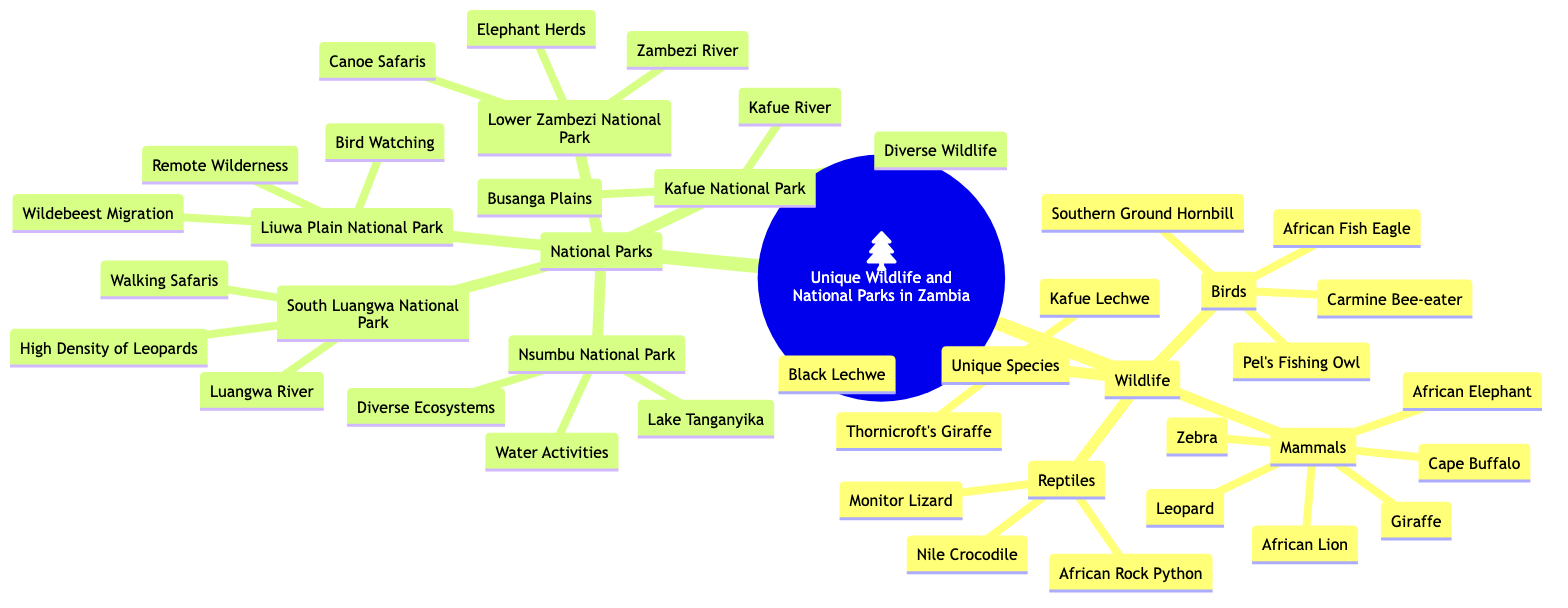What unique species are found in Zambia? The diagram lists "Kafue Lechwe," "Black Lechwe," and "Thornicroft's Giraffe" under the Unique Species branch of Wildlife. These are identified as unique to the region.
Answer: Kafue Lechwe, Black Lechwe, Thornicroft's Giraffe How many mammals are listed in the wildlife section? In the Wildlife section, there are six mammals mentioned: African Elephant, African Lion, Leopard, Cape Buffalo, Zebra, and Giraffe. By counting these, we arrive at the total.
Answer: 6 What national park is highlighted for walking safaris? The South Luangwa National Park branch directly states "Walking Safaris" as one of its highlights. This indicates its significance for such activities.
Answer: South Luangwa National Park Which national park includes the Zambezi River? The Lower Zambezi National Park is specifically noted for having the Zambezi River as part of its highlights. This can be found directly under that national park's section.
Answer: Lower Zambezi National Park Identify one bird species present in Zambia's wildlife. The Birds section under Wildlife includes several species. Notably, "African Fish Eagle" is one of the species mentioned, and it is a common bird in Zambia.
Answer: African Fish Eagle What is the highlight of Liuwa Plain National Park? Liuwa Plain National Park includes "Wildebeest Migration" as one of its highlights, indicating a significant natural event that occurs there.
Answer: Wildebeest Migration Which wildlife section has the fewest categories? The reptiles section contains three species: Nile Crocodile, African Rock Python, and Monitor Lizard, while other categories have more. Thus, reptiles have the fewest.
Answer: Reptiles How many national parks are mentioned in the diagram? The National Parks branch lists five parks: Kafue National Park, South Luangwa National Park, Lower Zambezi National Park, Liuwa Plain National Park, and Nsumbu National Park. Counting these, the total is five.
Answer: 5 